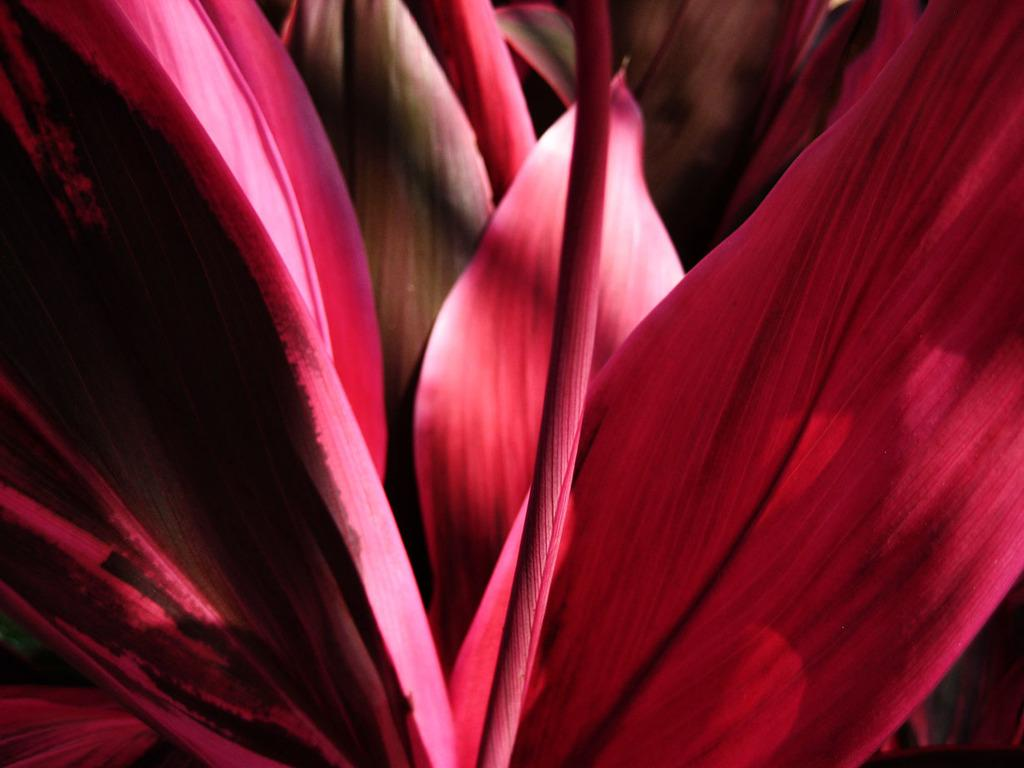What type of living organism can be seen in the image? A: There is a plant in the image. What part of the plant is visible in the front of the image? The leaves of the plant are visible in the front of the image. What is the tendency of the light to change color in the image? There is no mention of light in the image, so we cannot determine any tendency for the light to change color. 